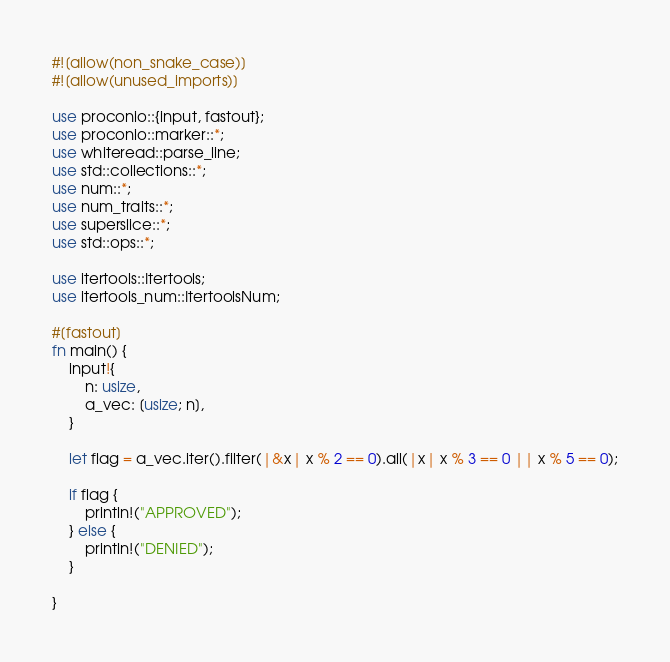Convert code to text. <code><loc_0><loc_0><loc_500><loc_500><_Rust_>#![allow(non_snake_case)]
#![allow(unused_imports)]

use proconio::{input, fastout};
use proconio::marker::*;
use whiteread::parse_line;
use std::collections::*;
use num::*;
use num_traits::*;
use superslice::*;
use std::ops::*;

use itertools::Itertools;
use itertools_num::ItertoolsNum;

#[fastout]
fn main() {
    input!{
        n: usize,
        a_vec: [usize; n],
    }

    let flag = a_vec.iter().filter(|&x| x % 2 == 0).all(|x| x % 3 == 0 || x % 5 == 0);

    if flag {
        println!("APPROVED");
    } else {
        println!("DENIED");
    }
    
}
</code> 